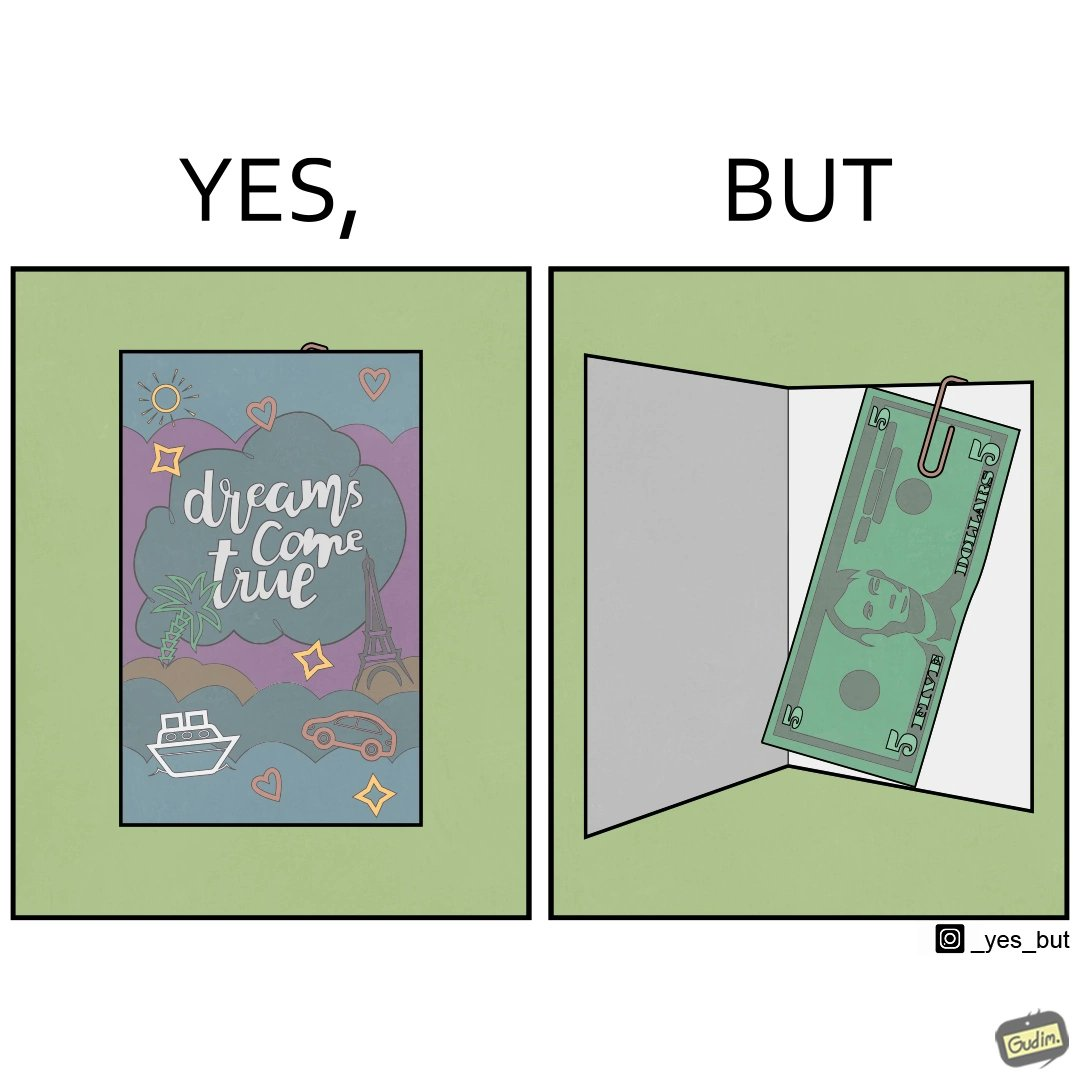What makes this image funny or satirical? The overall image is funny because while the front of the card gives hope that the person receiving this card will have one of their dreams come true but opening the card reveals only 5 dollars which is nowhere enough to fulfil any kind of dream. 